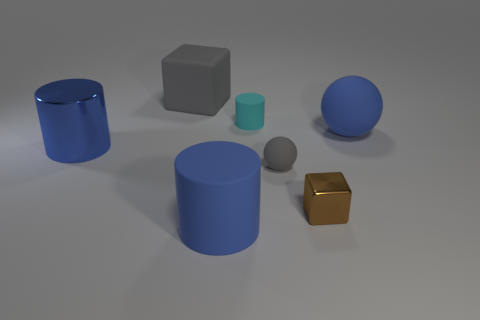Is the number of big blue shiny cylinders less than the number of small green matte cubes?
Make the answer very short. No. There is a large cylinder that is behind the big blue cylinder on the right side of the shiny cylinder; is there a thing behind it?
Your response must be concise. Yes. There is a gray thing that is in front of the large blue rubber ball; does it have the same shape as the large gray rubber thing?
Provide a succinct answer. No. Is the number of blue cylinders in front of the large gray rubber block greater than the number of gray rubber spheres?
Keep it short and to the point. Yes. Do the large matte object that is behind the large blue sphere and the small sphere have the same color?
Offer a terse response. Yes. Is there any other thing that has the same color as the metallic block?
Provide a succinct answer. No. What is the color of the block that is behind the blue rubber object behind the metallic thing that is to the left of the tiny matte cylinder?
Keep it short and to the point. Gray. Is the metallic cylinder the same size as the cyan cylinder?
Keep it short and to the point. No. What number of rubber cylinders have the same size as the blue metal thing?
Your answer should be compact. 1. There is a thing that is the same color as the large block; what is its shape?
Give a very brief answer. Sphere. 